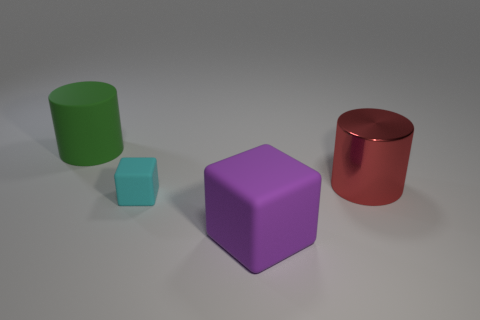The matte cube that is behind the large rubber object in front of the rubber thing behind the metal object is what color?
Your answer should be compact. Cyan. Are the tiny thing and the big green object made of the same material?
Provide a succinct answer. Yes. Are there any red cylinders that have the same size as the cyan matte thing?
Ensure brevity in your answer.  No. There is a green thing that is the same size as the purple matte cube; what is it made of?
Ensure brevity in your answer.  Rubber. Are there any other big objects that have the same shape as the green thing?
Your answer should be compact. Yes. There is a big matte thing that is behind the metallic cylinder; what is its shape?
Give a very brief answer. Cylinder. How many rubber cubes are there?
Your response must be concise. 2. There is a large block that is the same material as the green object; what color is it?
Ensure brevity in your answer.  Purple. What number of big objects are rubber things or purple rubber cubes?
Give a very brief answer. 2. What number of shiny cylinders are right of the cyan cube?
Ensure brevity in your answer.  1. 